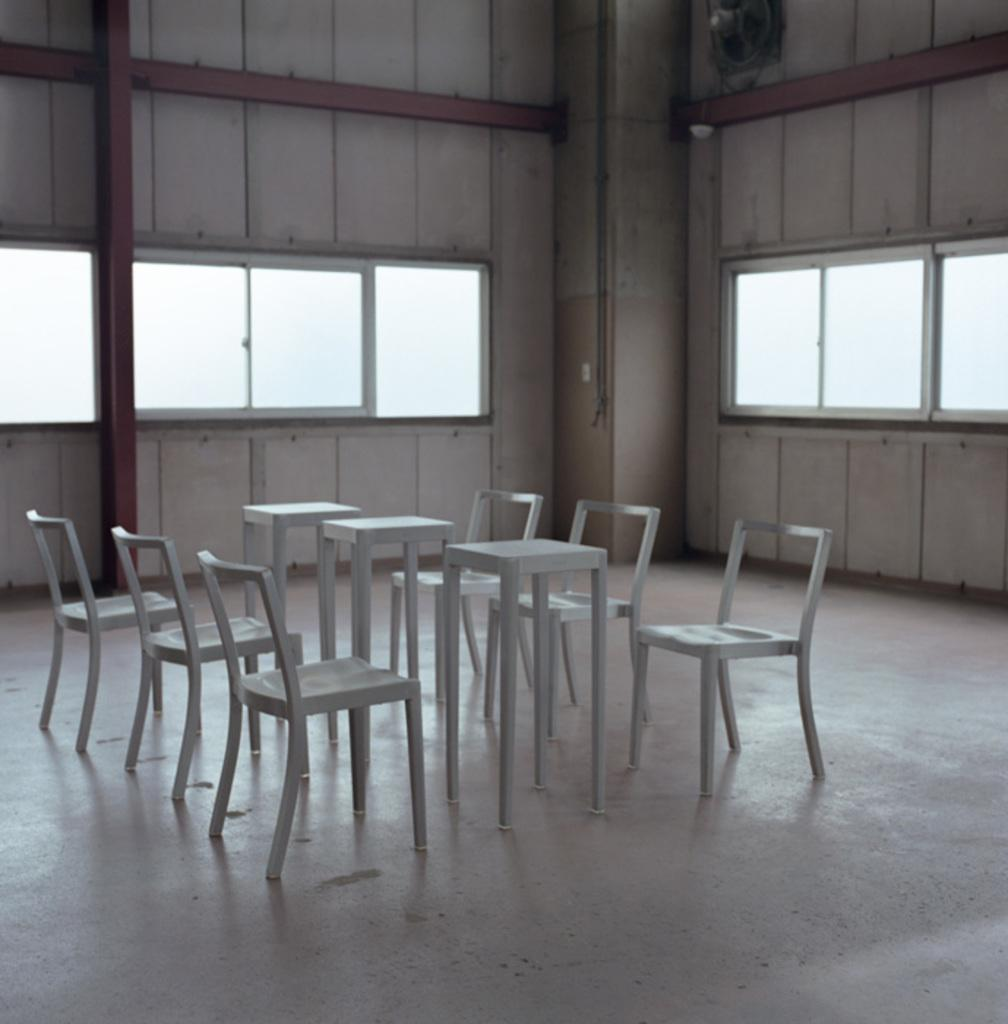What type of furniture is present in the image? There are tables and chairs in the image. Where are the tables and chairs located? The tables and chairs are on the floor. What can be seen on the wall in the background of the image? There are glass windows on the wall in the background of the image. What type of grape is being recommended by the doctor in the image? There is no grape or doctor present in the image. What suggestion is being made by the doctor in the image? There is no doctor or suggestion present in the image. 